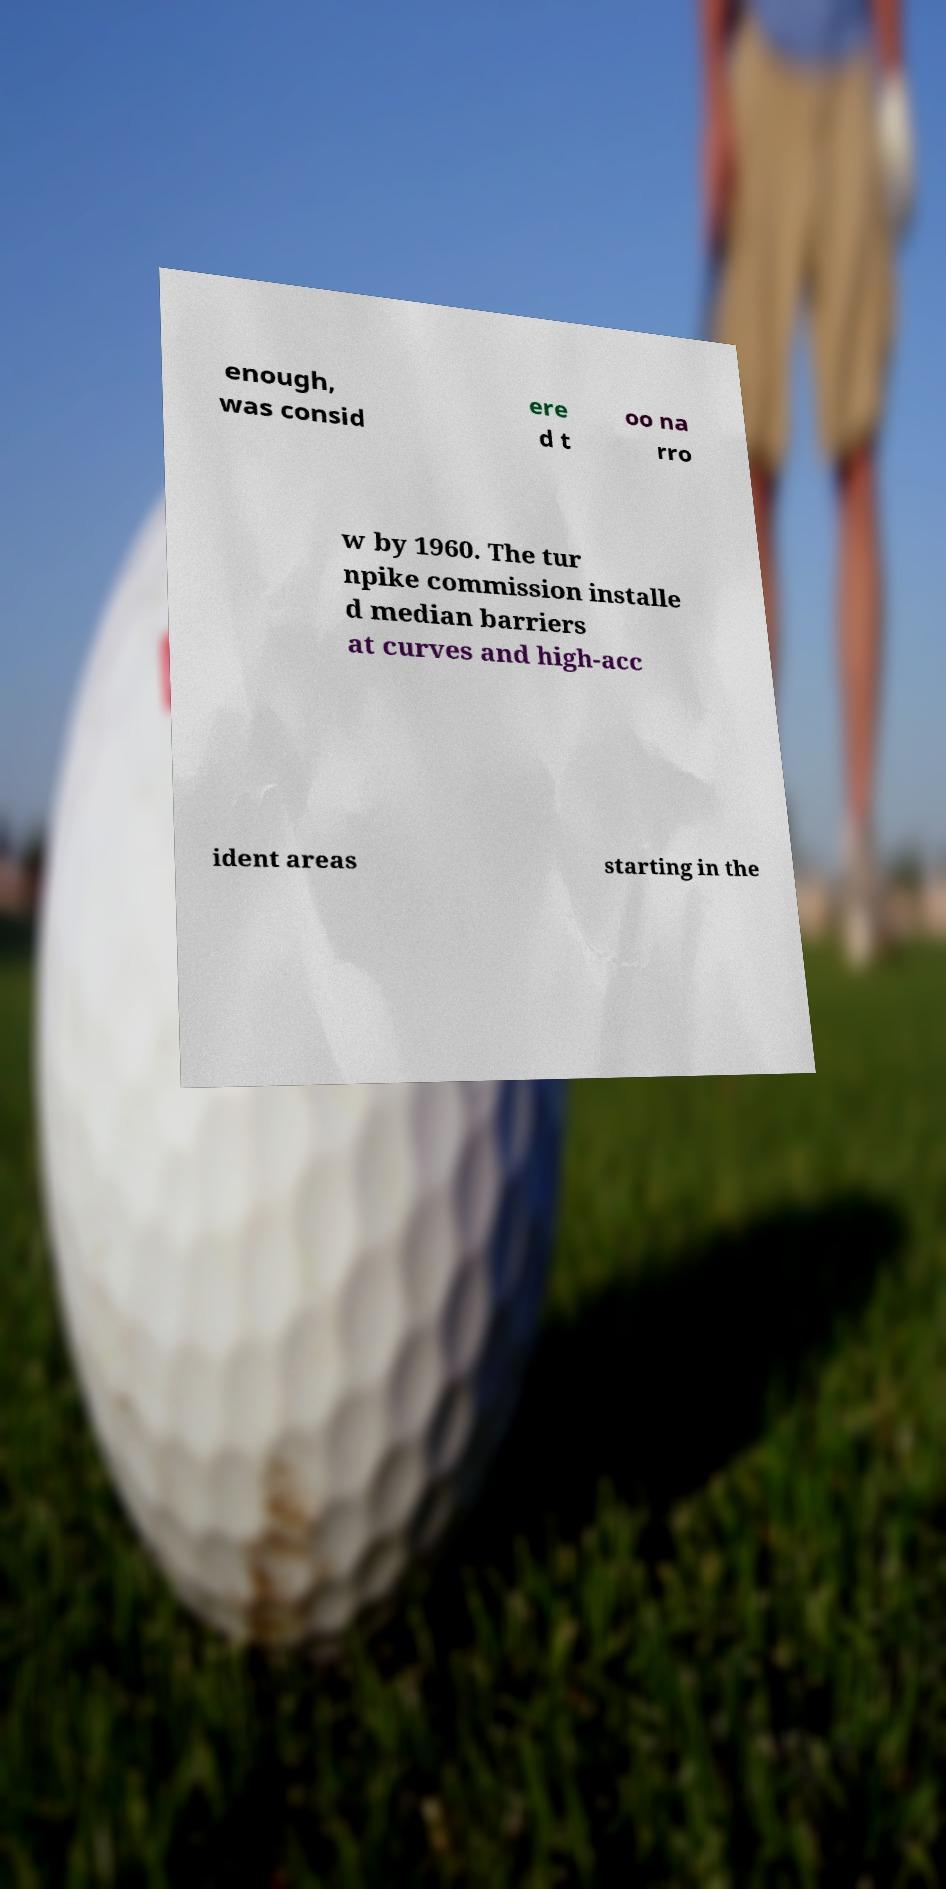What messages or text are displayed in this image? I need them in a readable, typed format. enough, was consid ere d t oo na rro w by 1960. The tur npike commission installe d median barriers at curves and high-acc ident areas starting in the 